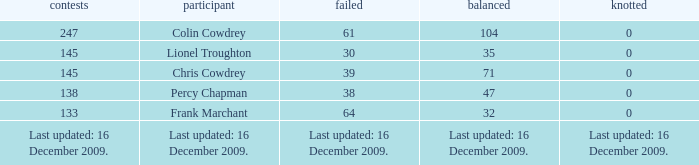Name the tie that has 71 drawn 0.0. 